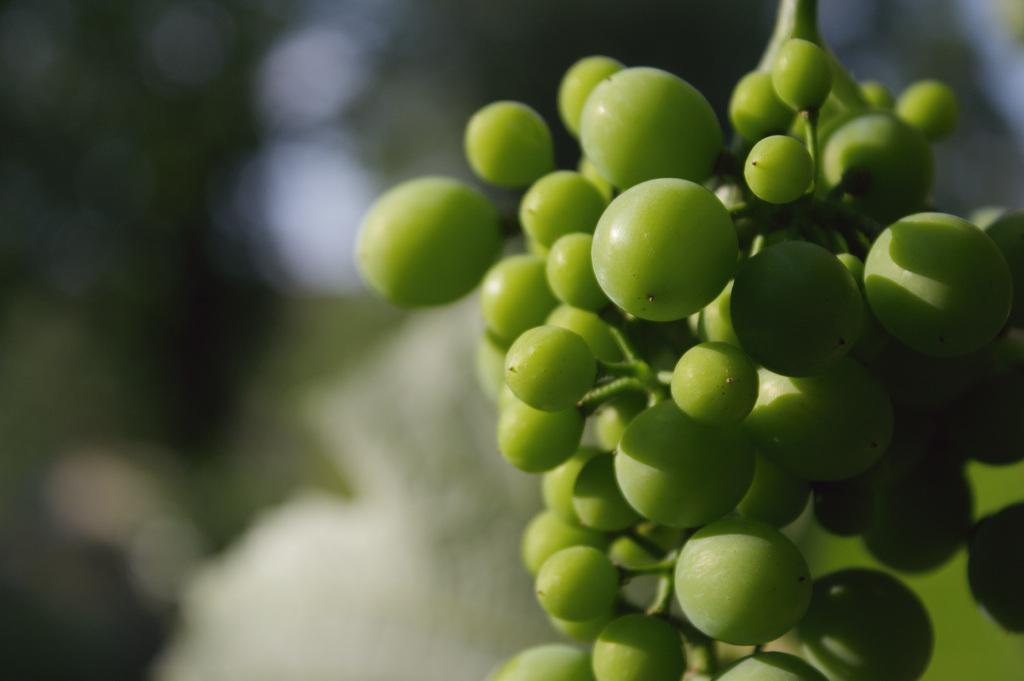What type of fruits can be seen in the image? There are green color fruits in the image. Can you describe the background of the image? The background of the image is blurred. What type of ice can be seen melting on the fruits in the image? There is no ice present in the image, and therefore no such melting can be observed. What type of blade is used to cut the fruits in the image? There is no blade visible in the image, and the fruits appear to be whole. 